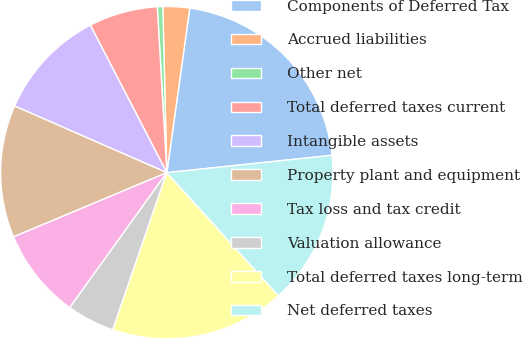Convert chart to OTSL. <chart><loc_0><loc_0><loc_500><loc_500><pie_chart><fcel>Components of Deferred Tax<fcel>Accrued liabilities<fcel>Other net<fcel>Total deferred taxes current<fcel>Intangible assets<fcel>Property plant and equipment<fcel>Tax loss and tax credit<fcel>Valuation allowance<fcel>Total deferred taxes long-term<fcel>Net deferred taxes<nl><fcel>21.12%<fcel>2.59%<fcel>0.53%<fcel>6.7%<fcel>10.82%<fcel>12.88%<fcel>8.76%<fcel>4.65%<fcel>17.0%<fcel>14.94%<nl></chart> 